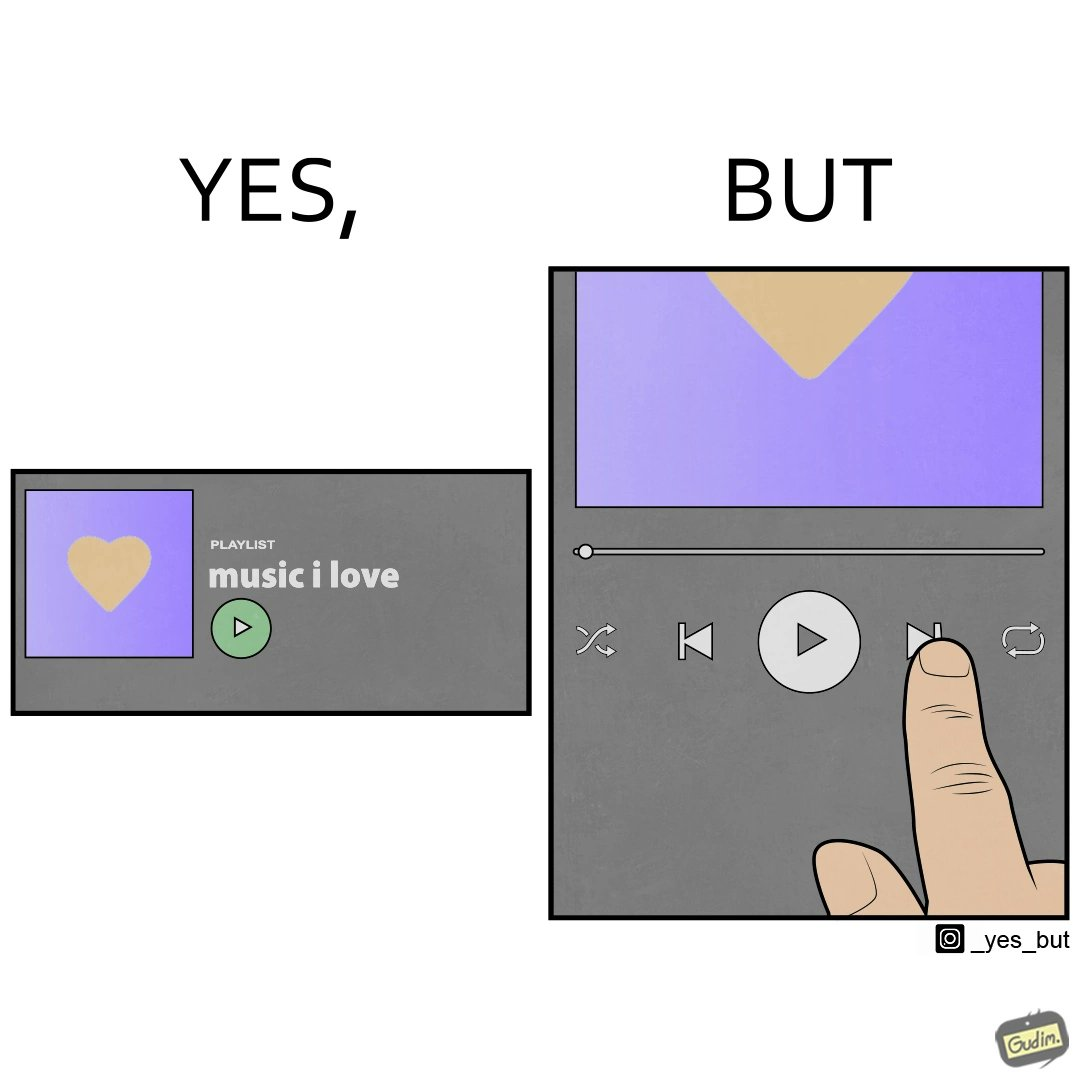Explain why this image is satirical. The image is funny because while the playlist is labelled "music I love" indicating that all the music in the playlist is very well liked by the user but the user is pressing play next button after listening to a few seconds of one of the audios in the playlist. 